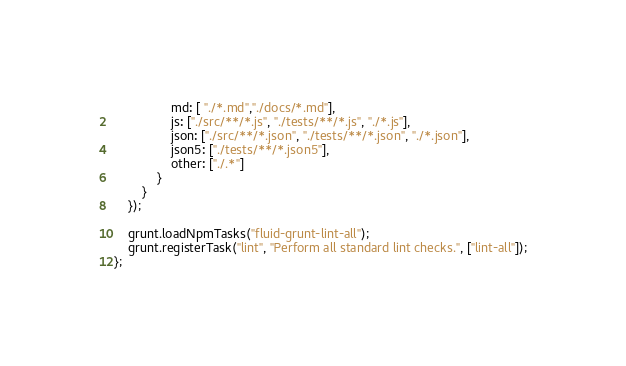Convert code to text. <code><loc_0><loc_0><loc_500><loc_500><_JavaScript_>                md: [ "./*.md","./docs/*.md"],
                js: ["./src/**/*.js", "./tests/**/*.js", "./*.js"],
                json: ["./src/**/*.json", "./tests/**/*.json", "./*.json"],
                json5: ["./tests/**/*.json5"],
                other: ["./.*"]
            }
        }
    });

    grunt.loadNpmTasks("fluid-grunt-lint-all");
    grunt.registerTask("lint", "Perform all standard lint checks.", ["lint-all"]);
};
</code> 